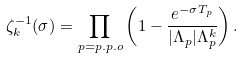<formula> <loc_0><loc_0><loc_500><loc_500>\zeta _ { k } ^ { - 1 } ( \sigma ) = \prod _ { p = p . p . o } \left ( 1 - \frac { e ^ { - \sigma T _ { p } } } { | \Lambda _ { p } | \Lambda _ { p } ^ { k } } \right ) .</formula> 